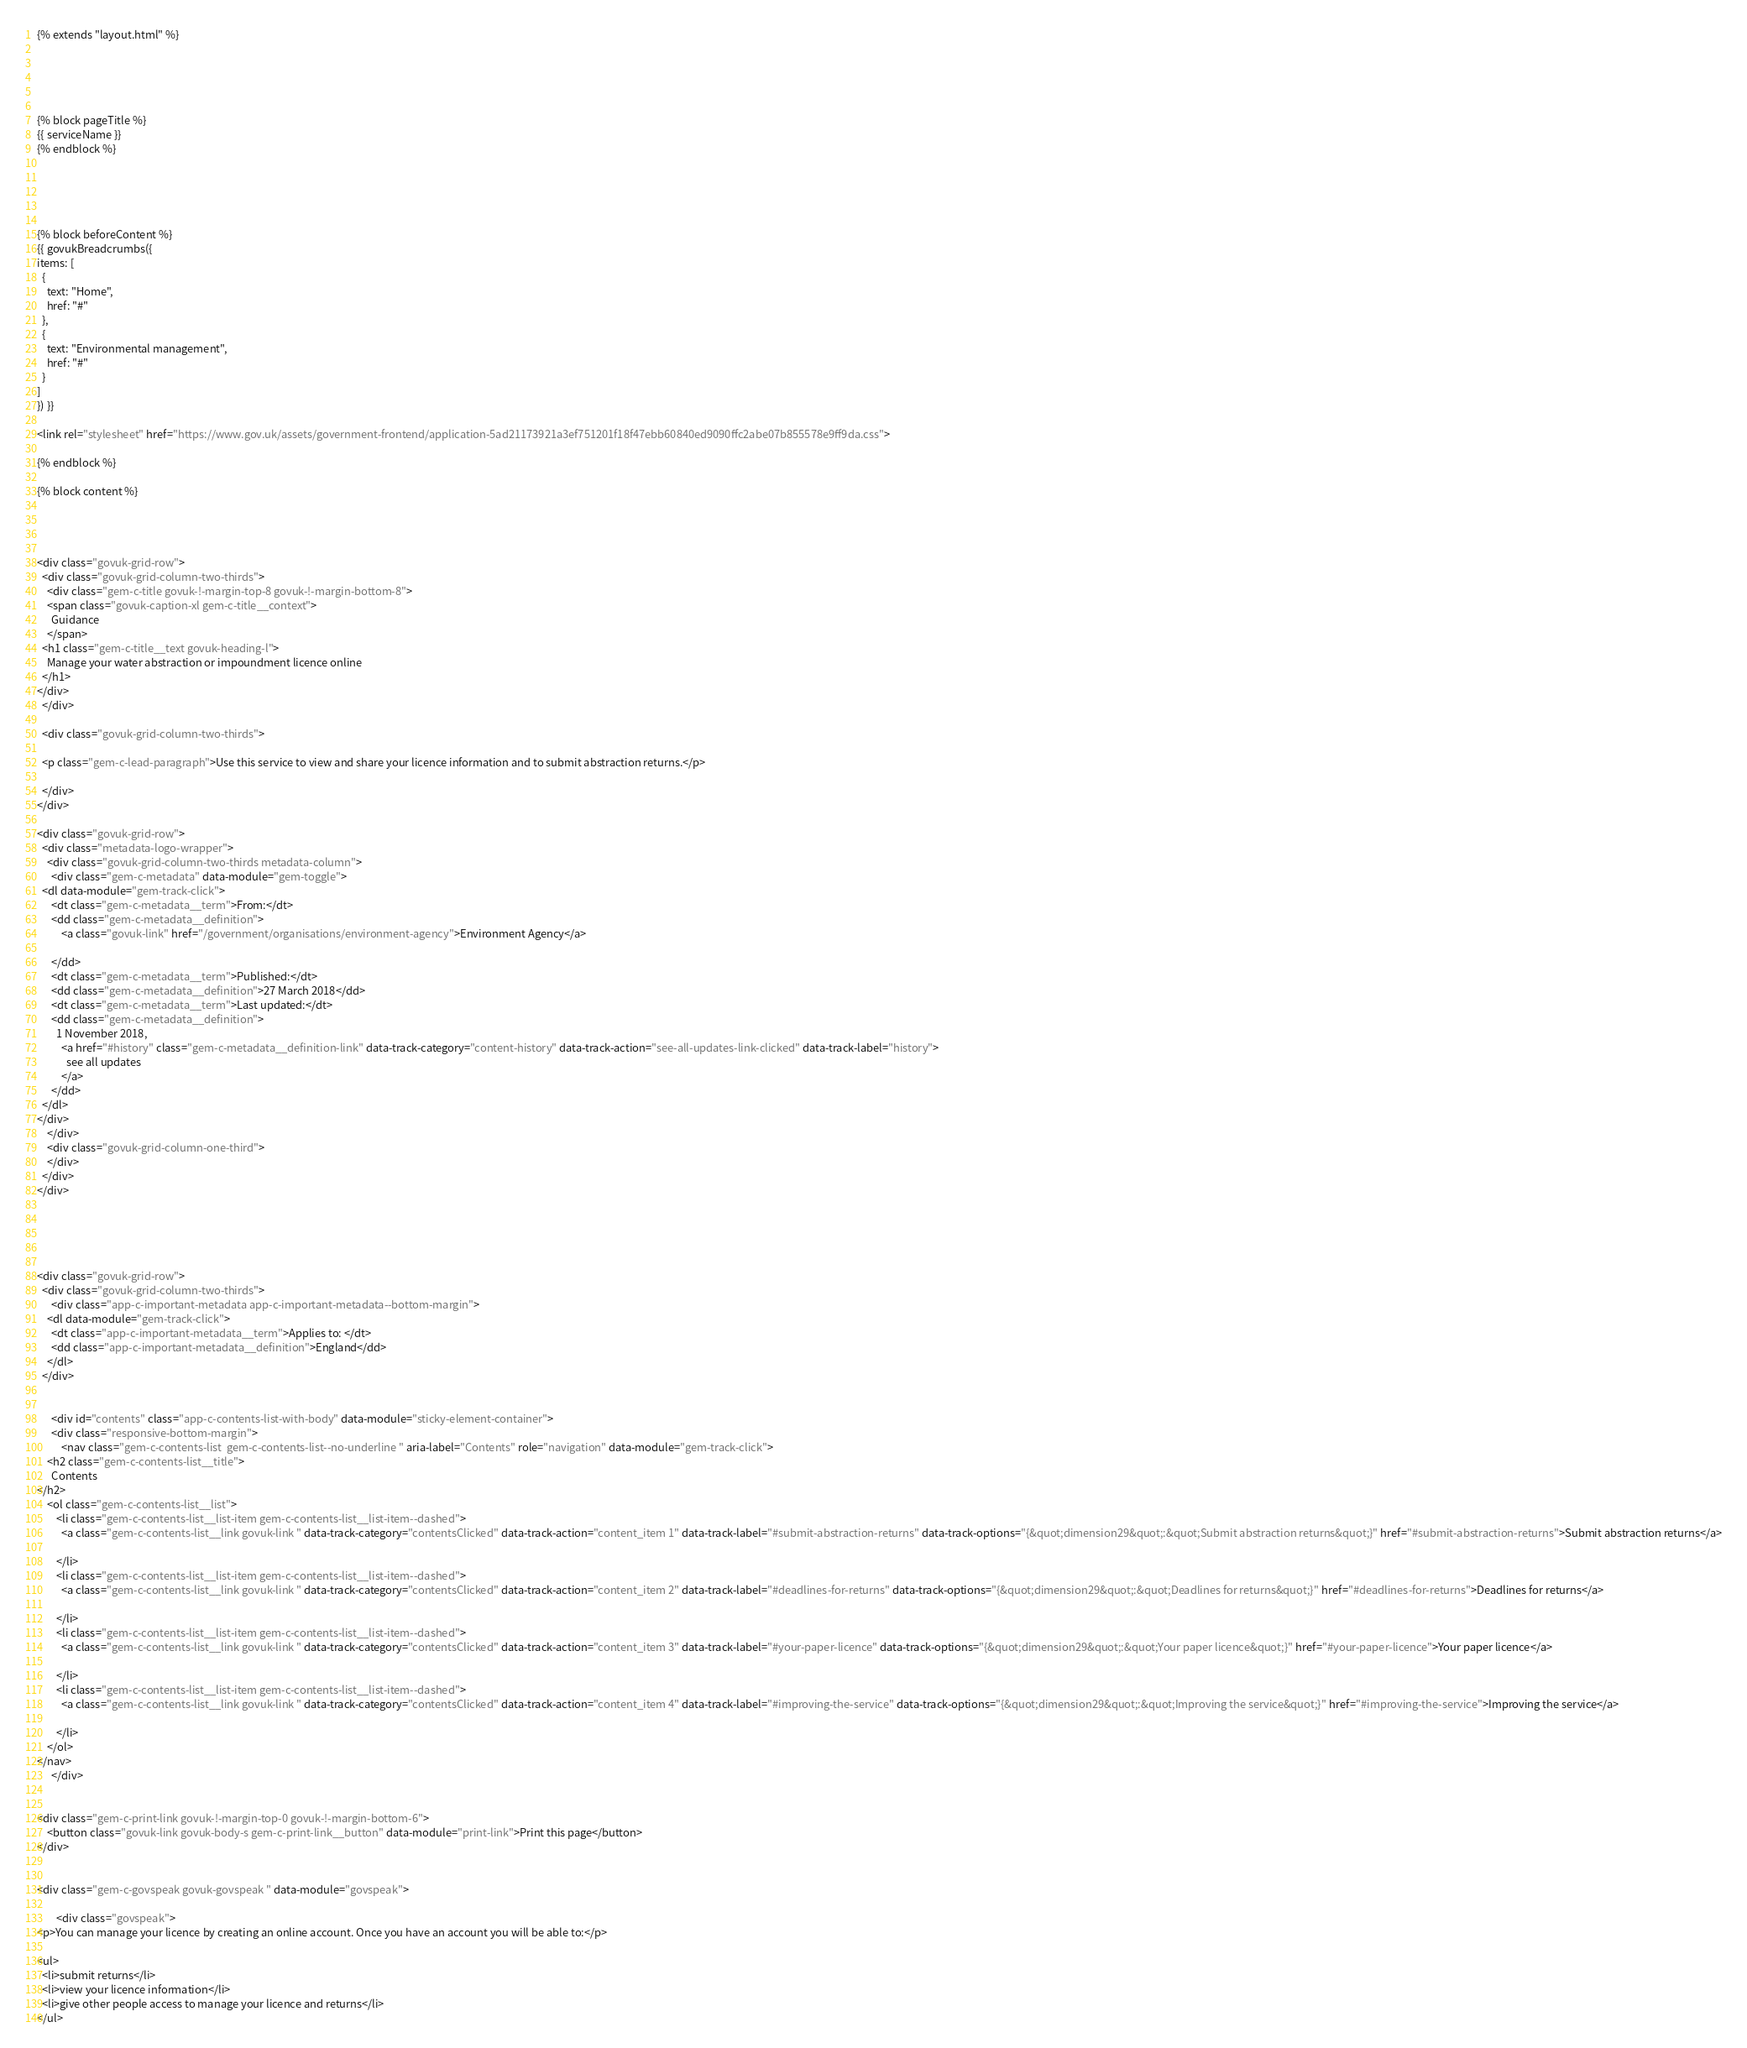<code> <loc_0><loc_0><loc_500><loc_500><_HTML_>

{% extends "layout.html" %}





{% block pageTitle %}
{{ serviceName }}
{% endblock %}





{% block beforeContent %}
{{ govukBreadcrumbs({
items: [
  {
    text: "Home",
    href: "#"
  },
  {
    text: "Environmental management",
    href: "#"
  }
]
}) }}

<link rel="stylesheet" href="https://www.gov.uk/assets/government-frontend/application-5ad21173921a3ef751201f18f47ebb60840ed9090ffc2abe07b855578e9ff9da.css">

{% endblock %}

{% block content %}




<div class="govuk-grid-row">
  <div class="govuk-grid-column-two-thirds">
    <div class="gem-c-title govuk-!-margin-top-8 govuk-!-margin-bottom-8">
    <span class="govuk-caption-xl gem-c-title__context">
      Guidance
    </span>
  <h1 class="gem-c-title__text govuk-heading-l">
    Manage your water abstraction or impoundment licence online
  </h1>
</div>
  </div>

  <div class="govuk-grid-column-two-thirds">

  <p class="gem-c-lead-paragraph">Use this service to view and share your licence information and to submit abstraction returns.</p>

  </div>
</div>

<div class="govuk-grid-row">
  <div class="metadata-logo-wrapper">
    <div class="govuk-grid-column-two-thirds metadata-column">
      <div class="gem-c-metadata" data-module="gem-toggle">
  <dl data-module="gem-track-click">
      <dt class="gem-c-metadata__term">From:</dt>
      <dd class="gem-c-metadata__definition">
          <a class="govuk-link" href="/government/organisations/environment-agency">Environment Agency</a>

      </dd>
      <dt class="gem-c-metadata__term">Published:</dt>
      <dd class="gem-c-metadata__definition">27 March 2018</dd>
      <dt class="gem-c-metadata__term">Last updated:</dt>
      <dd class="gem-c-metadata__definition">
        1 November 2018,
          <a href="#history" class="gem-c-metadata__definition-link" data-track-category="content-history" data-track-action="see-all-updates-link-clicked" data-track-label="history">
            see all updates
          </a>
      </dd>
  </dl>
</div>
    </div>
    <div class="govuk-grid-column-one-third">
    </div>
  </div>
</div>





<div class="govuk-grid-row">
  <div class="govuk-grid-column-two-thirds">
      <div class="app-c-important-metadata app-c-important-metadata--bottom-margin">
    <dl data-module="gem-track-click">
      <dt class="app-c-important-metadata__term">Applies to: </dt>
      <dd class="app-c-important-metadata__definition">England</dd>
    </dl>
  </div>


      <div id="contents" class="app-c-contents-list-with-body" data-module="sticky-element-container">
      <div class="responsive-bottom-margin">
          <nav class="gem-c-contents-list  gem-c-contents-list--no-underline " aria-label="Contents" role="navigation" data-module="gem-track-click">
    <h2 class="gem-c-contents-list__title">
      Contents
</h2>
    <ol class="gem-c-contents-list__list">
        <li class="gem-c-contents-list__list-item gem-c-contents-list__list-item--dashed">
          <a class="gem-c-contents-list__link govuk-link " data-track-category="contentsClicked" data-track-action="content_item 1" data-track-label="#submit-abstraction-returns" data-track-options="{&quot;dimension29&quot;:&quot;Submit abstraction returns&quot;}" href="#submit-abstraction-returns">Submit abstraction returns</a>

        </li>
        <li class="gem-c-contents-list__list-item gem-c-contents-list__list-item--dashed">
          <a class="gem-c-contents-list__link govuk-link " data-track-category="contentsClicked" data-track-action="content_item 2" data-track-label="#deadlines-for-returns" data-track-options="{&quot;dimension29&quot;:&quot;Deadlines for returns&quot;}" href="#deadlines-for-returns">Deadlines for returns</a>

        </li>
        <li class="gem-c-contents-list__list-item gem-c-contents-list__list-item--dashed">
          <a class="gem-c-contents-list__link govuk-link " data-track-category="contentsClicked" data-track-action="content_item 3" data-track-label="#your-paper-licence" data-track-options="{&quot;dimension29&quot;:&quot;Your paper licence&quot;}" href="#your-paper-licence">Your paper licence</a>

        </li>
        <li class="gem-c-contents-list__list-item gem-c-contents-list__list-item--dashed">
          <a class="gem-c-contents-list__link govuk-link " data-track-category="contentsClicked" data-track-action="content_item 4" data-track-label="#improving-the-service" data-track-options="{&quot;dimension29&quot;:&quot;Improving the service&quot;}" href="#improving-the-service">Improving the service</a>

        </li>
    </ol>
</nav>
      </div>


<div class="gem-c-print-link govuk-!-margin-top-0 govuk-!-margin-bottom-6">
    <button class="govuk-link govuk-body-s gem-c-print-link__button" data-module="print-link">Print this page</button>
</div>


<div class="gem-c-govspeak govuk-govspeak " data-module="govspeak">

        <div class="govspeak">
<p>You can manage your licence by creating an online account. Once you have an account you will be able to:</p>

<ul>
  <li>submit returns</li>
  <li>view your licence information</li>
  <li>give other people access to manage your licence and returns</li>
</ul>
</code> 